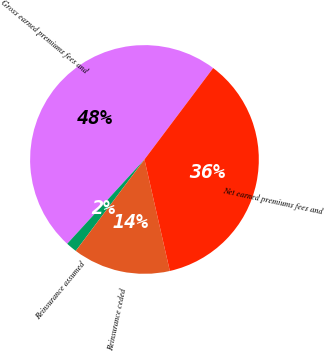Convert chart to OTSL. <chart><loc_0><loc_0><loc_500><loc_500><pie_chart><fcel>Gross earned premiums fees and<fcel>Reinsurance assumed<fcel>Reinsurance ceded<fcel>Net earned premiums fees and<nl><fcel>48.45%<fcel>1.55%<fcel>13.82%<fcel>36.18%<nl></chart> 